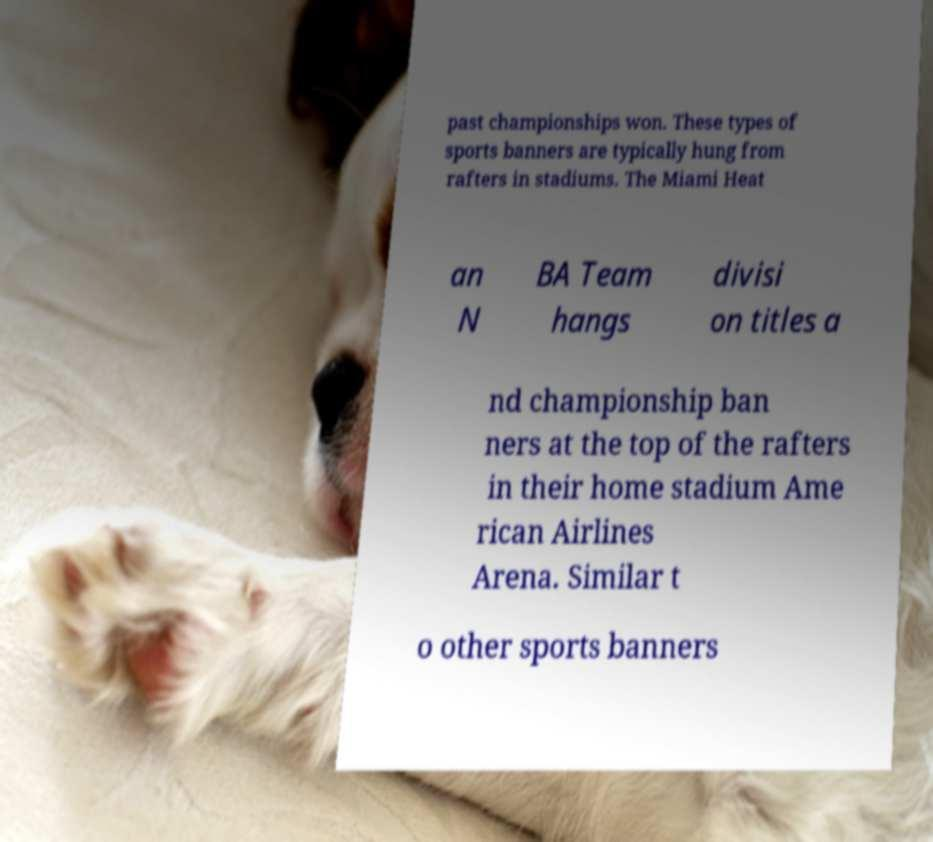What messages or text are displayed in this image? I need them in a readable, typed format. past championships won. These types of sports banners are typically hung from rafters in stadiums. The Miami Heat an N BA Team hangs divisi on titles a nd championship ban ners at the top of the rafters in their home stadium Ame rican Airlines Arena. Similar t o other sports banners 